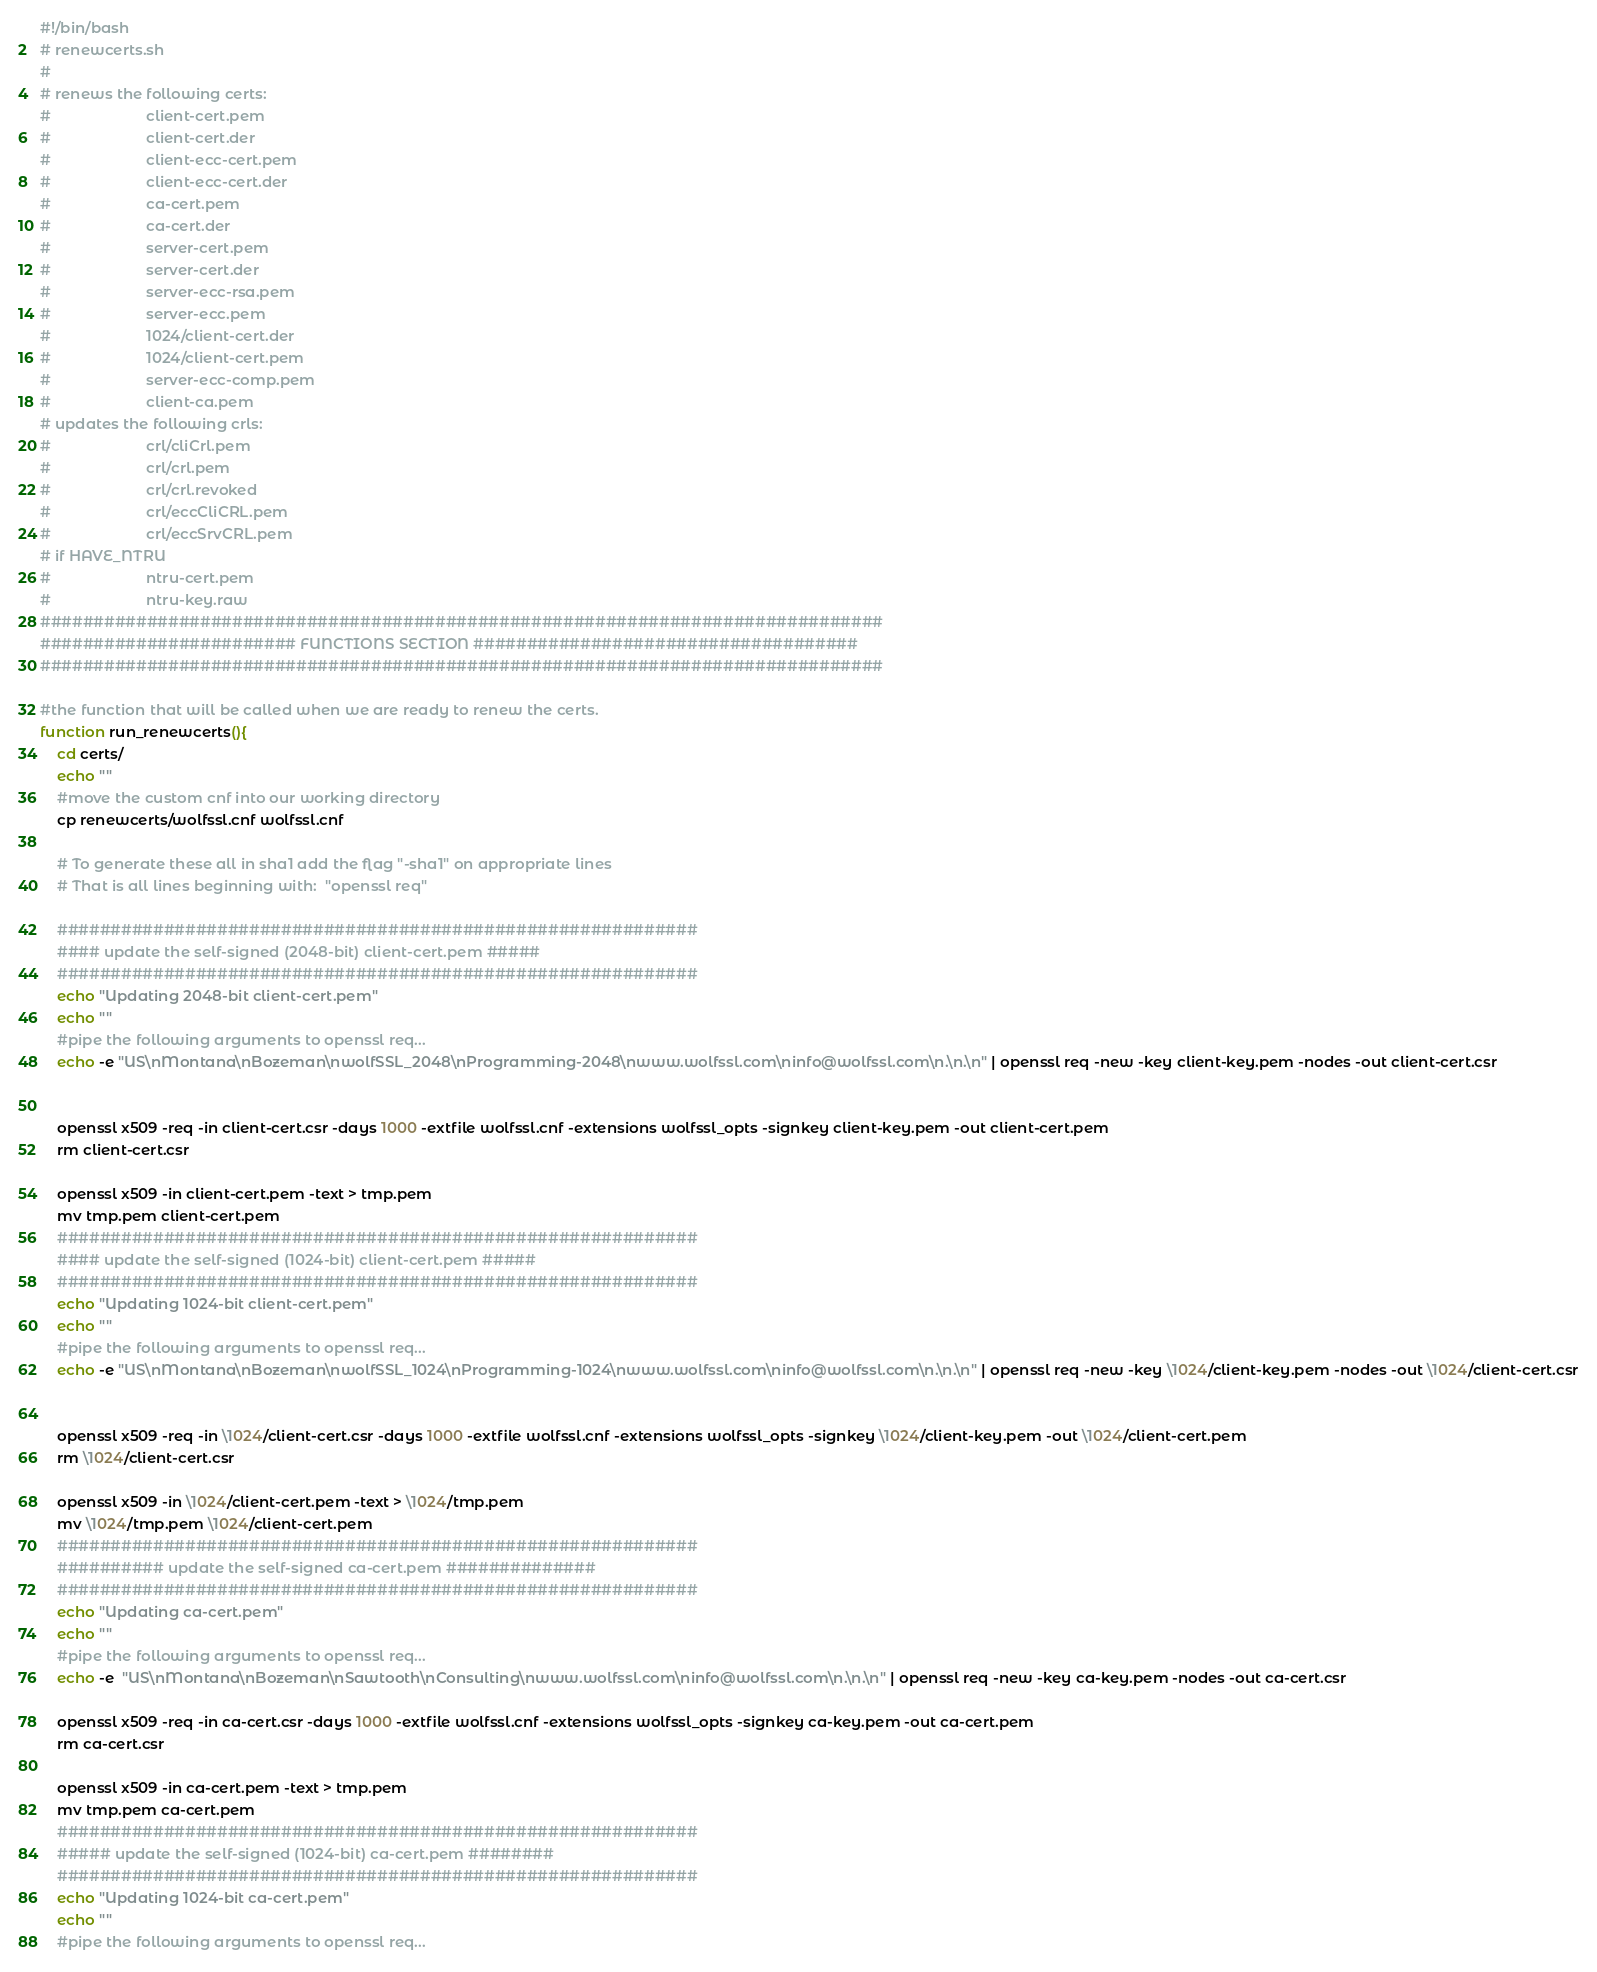<code> <loc_0><loc_0><loc_500><loc_500><_Bash_>#!/bin/bash
# renewcerts.sh
#
# renews the following certs:
#                       client-cert.pem
#                       client-cert.der
#                       client-ecc-cert.pem
#                       client-ecc-cert.der
#                       ca-cert.pem
#                       ca-cert.der
#                       server-cert.pem
#                       server-cert.der
#                       server-ecc-rsa.pem
#                       server-ecc.pem
#                       1024/client-cert.der
#                       1024/client-cert.pem
#                       server-ecc-comp.pem
#                       client-ca.pem
# updates the following crls:
#                       crl/cliCrl.pem
#                       crl/crl.pem
#                       crl/crl.revoked
#                       crl/eccCliCRL.pem
#                       crl/eccSrvCRL.pem
# if HAVE_NTRU
#                       ntru-cert.pem
#                       ntru-key.raw
###############################################################################
######################## FUNCTIONS SECTION ####################################
###############################################################################

#the function that will be called when we are ready to renew the certs.
function run_renewcerts(){
    cd certs/
    echo ""
    #move the custom cnf into our working directory
    cp renewcerts/wolfssl.cnf wolfssl.cnf

    # To generate these all in sha1 add the flag "-sha1" on appropriate lines
    # That is all lines beginning with:  "openssl req"

    ############################################################
    #### update the self-signed (2048-bit) client-cert.pem #####
    ############################################################
    echo "Updating 2048-bit client-cert.pem"
    echo ""
    #pipe the following arguments to openssl req...
    echo -e "US\nMontana\nBozeman\nwolfSSL_2048\nProgramming-2048\nwww.wolfssl.com\ninfo@wolfssl.com\n.\n.\n" | openssl req -new -key client-key.pem -nodes -out client-cert.csr


    openssl x509 -req -in client-cert.csr -days 1000 -extfile wolfssl.cnf -extensions wolfssl_opts -signkey client-key.pem -out client-cert.pem
    rm client-cert.csr

    openssl x509 -in client-cert.pem -text > tmp.pem
    mv tmp.pem client-cert.pem
    ############################################################
    #### update the self-signed (1024-bit) client-cert.pem #####
    ############################################################
    echo "Updating 1024-bit client-cert.pem"
    echo ""
    #pipe the following arguments to openssl req...
    echo -e "US\nMontana\nBozeman\nwolfSSL_1024\nProgramming-1024\nwww.wolfssl.com\ninfo@wolfssl.com\n.\n.\n" | openssl req -new -key \1024/client-key.pem -nodes -out \1024/client-cert.csr


    openssl x509 -req -in \1024/client-cert.csr -days 1000 -extfile wolfssl.cnf -extensions wolfssl_opts -signkey \1024/client-key.pem -out \1024/client-cert.pem
    rm \1024/client-cert.csr

    openssl x509 -in \1024/client-cert.pem -text > \1024/tmp.pem
    mv \1024/tmp.pem \1024/client-cert.pem
    ############################################################
    ########## update the self-signed ca-cert.pem ##############
    ############################################################
    echo "Updating ca-cert.pem"
    echo ""
    #pipe the following arguments to openssl req...
    echo -e  "US\nMontana\nBozeman\nSawtooth\nConsulting\nwww.wolfssl.com\ninfo@wolfssl.com\n.\n.\n" | openssl req -new -key ca-key.pem -nodes -out ca-cert.csr

    openssl x509 -req -in ca-cert.csr -days 1000 -extfile wolfssl.cnf -extensions wolfssl_opts -signkey ca-key.pem -out ca-cert.pem
    rm ca-cert.csr

    openssl x509 -in ca-cert.pem -text > tmp.pem
    mv tmp.pem ca-cert.pem
    ############################################################
    ##### update the self-signed (1024-bit) ca-cert.pem ########
    ############################################################
    echo "Updating 1024-bit ca-cert.pem"
    echo ""
    #pipe the following arguments to openssl req...</code> 